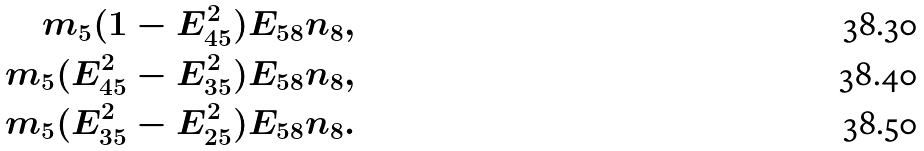<formula> <loc_0><loc_0><loc_500><loc_500>m _ { 5 } ( 1 - E _ { 4 5 } ^ { 2 } ) E _ { 5 8 } n _ { 8 } , \\ m _ { 5 } ( E _ { 4 5 } ^ { 2 } - E _ { 3 5 } ^ { 2 } ) E _ { 5 8 } n _ { 8 } , \\ m _ { 5 } ( E _ { 3 5 } ^ { 2 } - E _ { 2 5 } ^ { 2 } ) E _ { 5 8 } n _ { 8 } .</formula> 